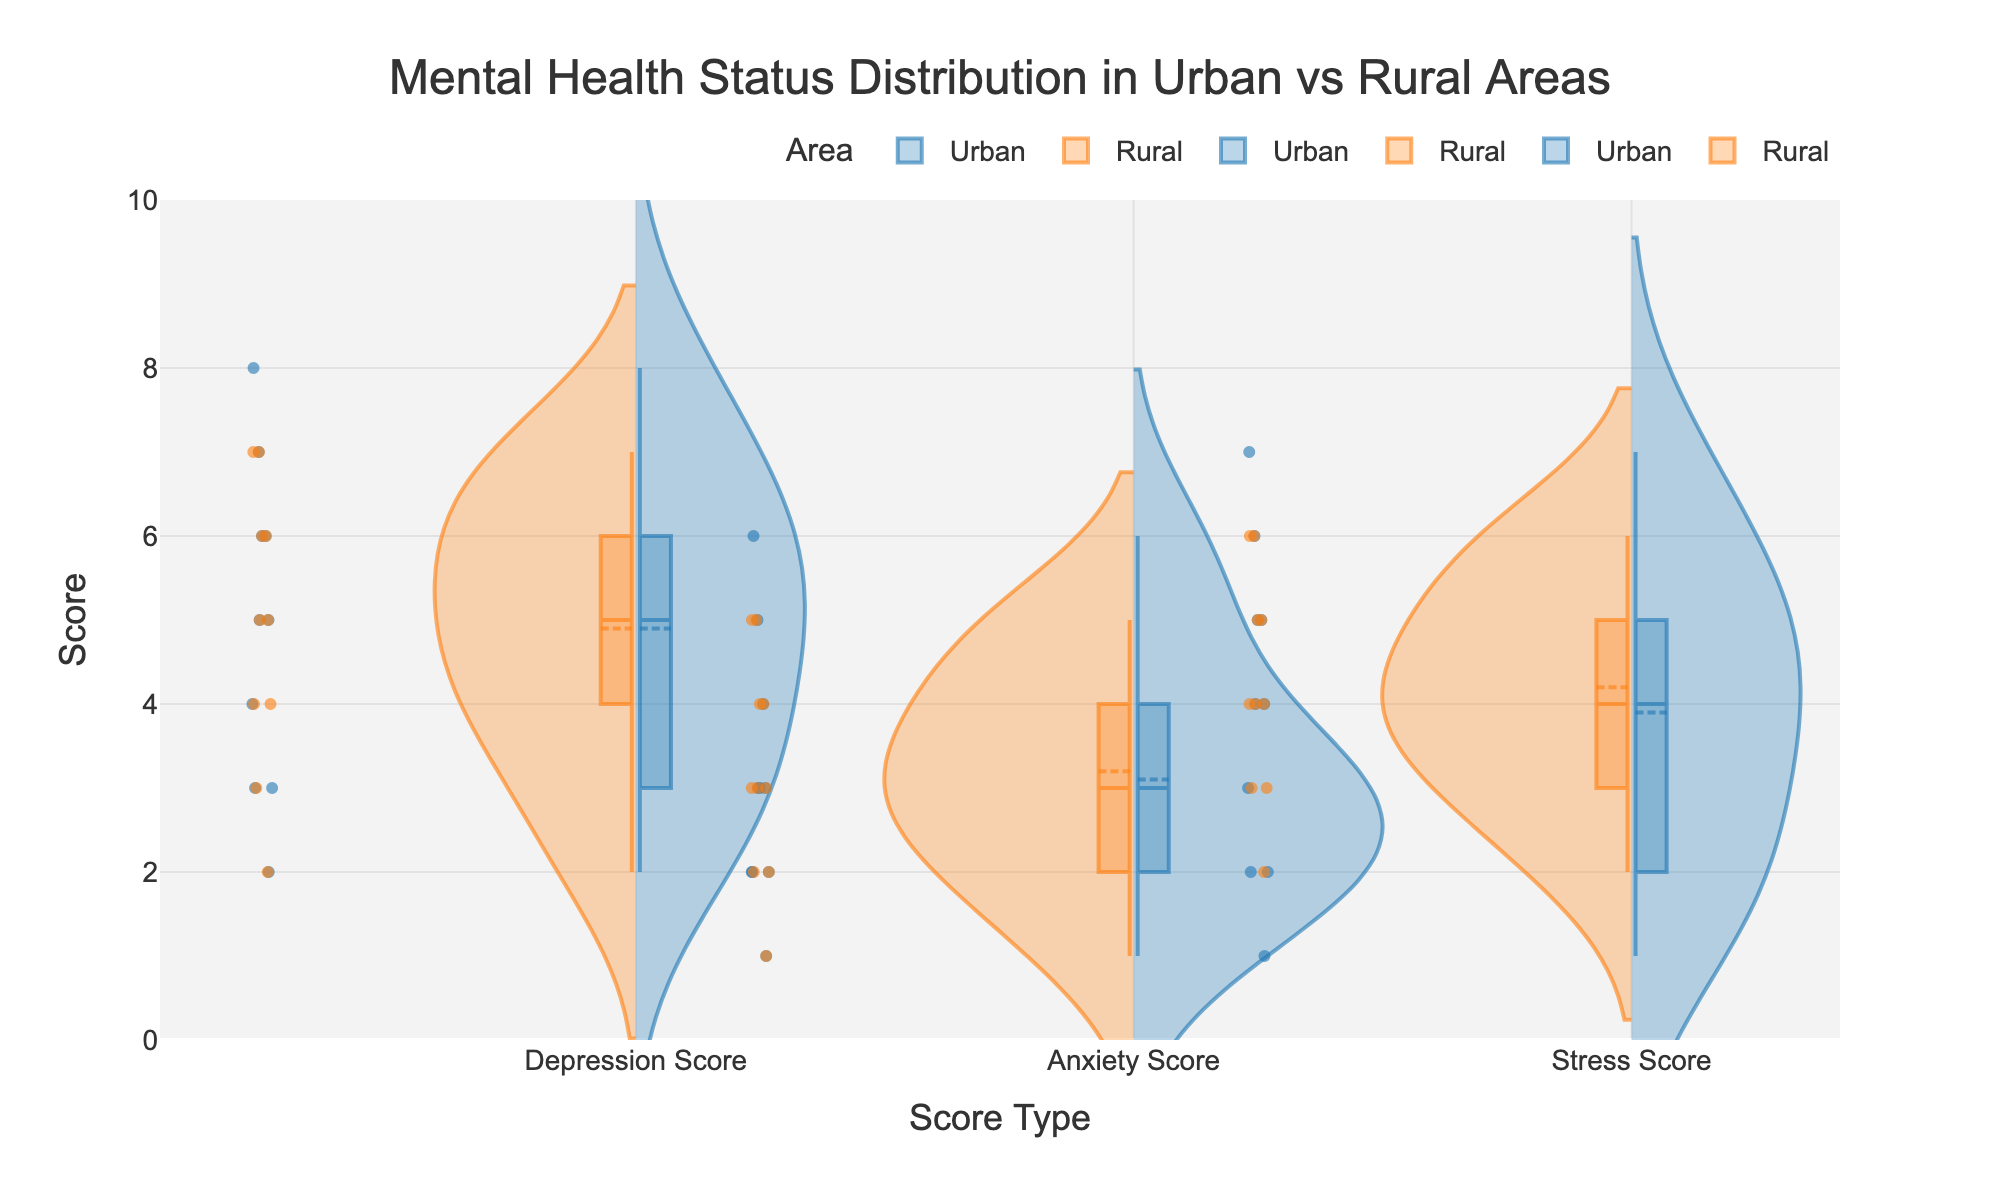What is the title of the figure? The title is displayed at the top center of the chart and reads "Mental Health Status Distribution in Urban vs Rural Areas".
Answer: Mental Health Status Distribution in Urban vs Rural Areas How many types of mental health scores are presented in the figure? The x-axis lists the types of scores which are 'Depression Score', 'Anxiety Score', and 'Stress Score'.
Answer: 3 Which area has higher values for Anxiety Score, Urban or Rural? The violin plot shows that values for Anxiety Score are higher for the Urban area, as it has data points recorded up to a higher score.
Answer: Urban What is the range of scores displayed on the y-axis? By looking at the y-axis, we can see the range is from 0 to 10.
Answer: 0 to 10 For the Depression Score, which area has a greater median value according to the box plot? The median is indicated by the white dot in the box plot within each violin. For the Depression Score, the Rural area has a higher median value than the Urban area.
Answer: Rural Compare the distribution spread of Stress Score for Urban and Rural areas. Which has more variability? By comparing the width of the violins for Stress Score, the Urban area shows more spread and variability in the scores compared to the Rural area.
Answer: Urban Which mental health status category shows the greatest difference in median values between Urban and Rural areas? By observing the white dots (medians) in the box plots within each violin, the greatest difference is found in the Depression Score category.
Answer: Depression Score For Anxiety Scores, what is the interquartile range (IQR) for the Urban area? The IQR can be determined by looking at the box part of the violin plot; it spans from the first quartile (Q1) to the third quartile (Q3). The exact values can be approximated from the plot.
Answer: Approximately 2 to 5 Are there any outliers shown for any of the score types in the Urban area? Outliers would be indicated as individual points outside the whiskers of the box plot within the violin plots. There are no clear outliers visible for the Urban area in any score type.
Answer: No How does the trend in variability for Depression Scores between Urban and Rural compare to the trend in variability for Stress Scores between the same areas? For Depression Scores, the Urban area shows less variability than the Rural area, while for Stress Scores, the Urban area shows more variability than the Rural area.
Answer: Opposite trends for each score 